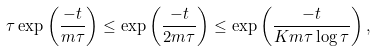Convert formula to latex. <formula><loc_0><loc_0><loc_500><loc_500>\tau \exp \left ( \frac { - t } { m \tau } \right ) \leq \exp \left ( \frac { - t } { 2 m \tau } \right ) \leq \exp \left ( \frac { - t } { K m \tau \log \tau } \right ) ,</formula> 